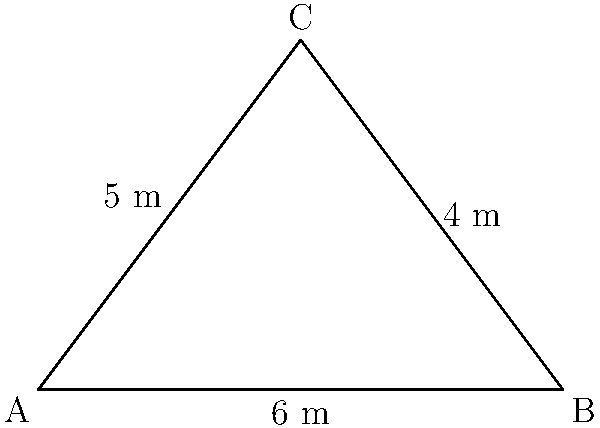While taking care of your grandparent's pet during their hospitalization, you decide to create a triangular herb garden for the pet's dietary needs. The garden plot has sides measuring 6 m, 5 m, and 4 m. Calculate the area of this triangular garden plot to determine how many herbs you can grow. To find the area of the triangular garden plot, we can use Heron's formula:

1) Heron's formula states that the area $A$ of a triangle with sides $a$, $b$, and $c$ is:

   $A = \sqrt{s(s-a)(s-b)(s-c)}$

   where $s$ is the semi-perimeter: $s = \frac{a+b+c}{2}$

2) In this case, $a = 6$ m, $b = 5$ m, and $c = 4$ m

3) Calculate the semi-perimeter:
   $s = \frac{6+5+4}{2} = \frac{15}{2} = 7.5$ m

4) Now substitute these values into Heron's formula:

   $A = \sqrt{7.5(7.5-6)(7.5-5)(7.5-4)}$
   $= \sqrt{7.5 \times 1.5 \times 2.5 \times 3.5}$
   $= \sqrt{98.4375}$

5) Simplify:
   $A \approx 9.92$ m²

Therefore, the area of the triangular garden plot is approximately 9.92 square meters.
Answer: $9.92$ m² 